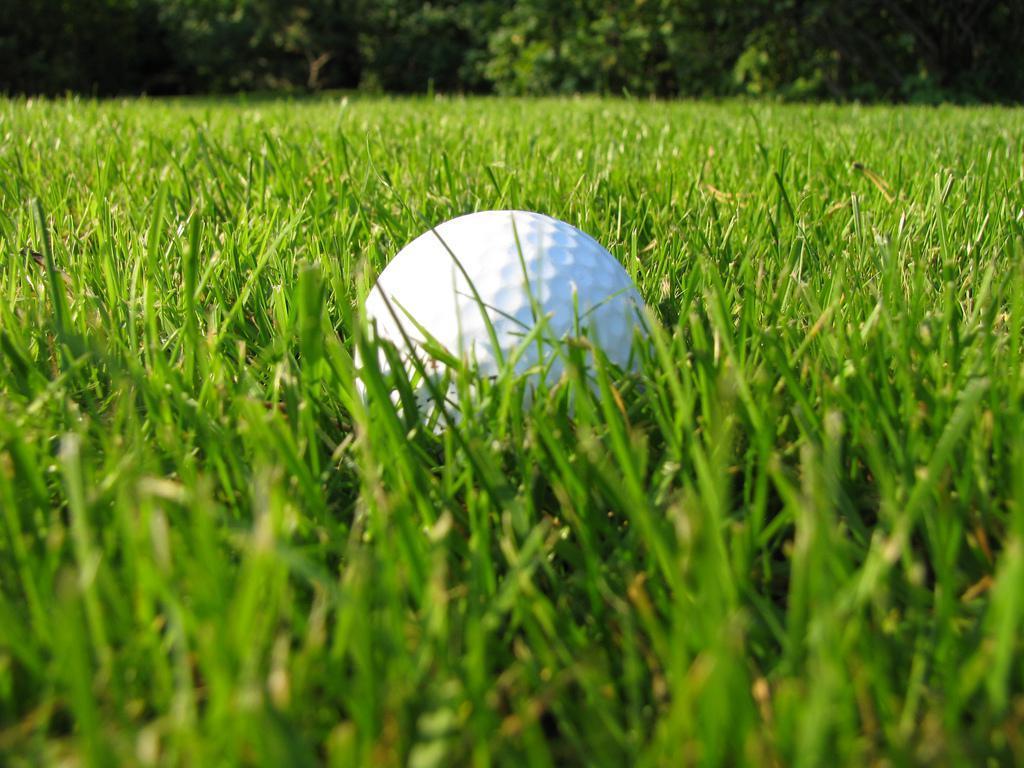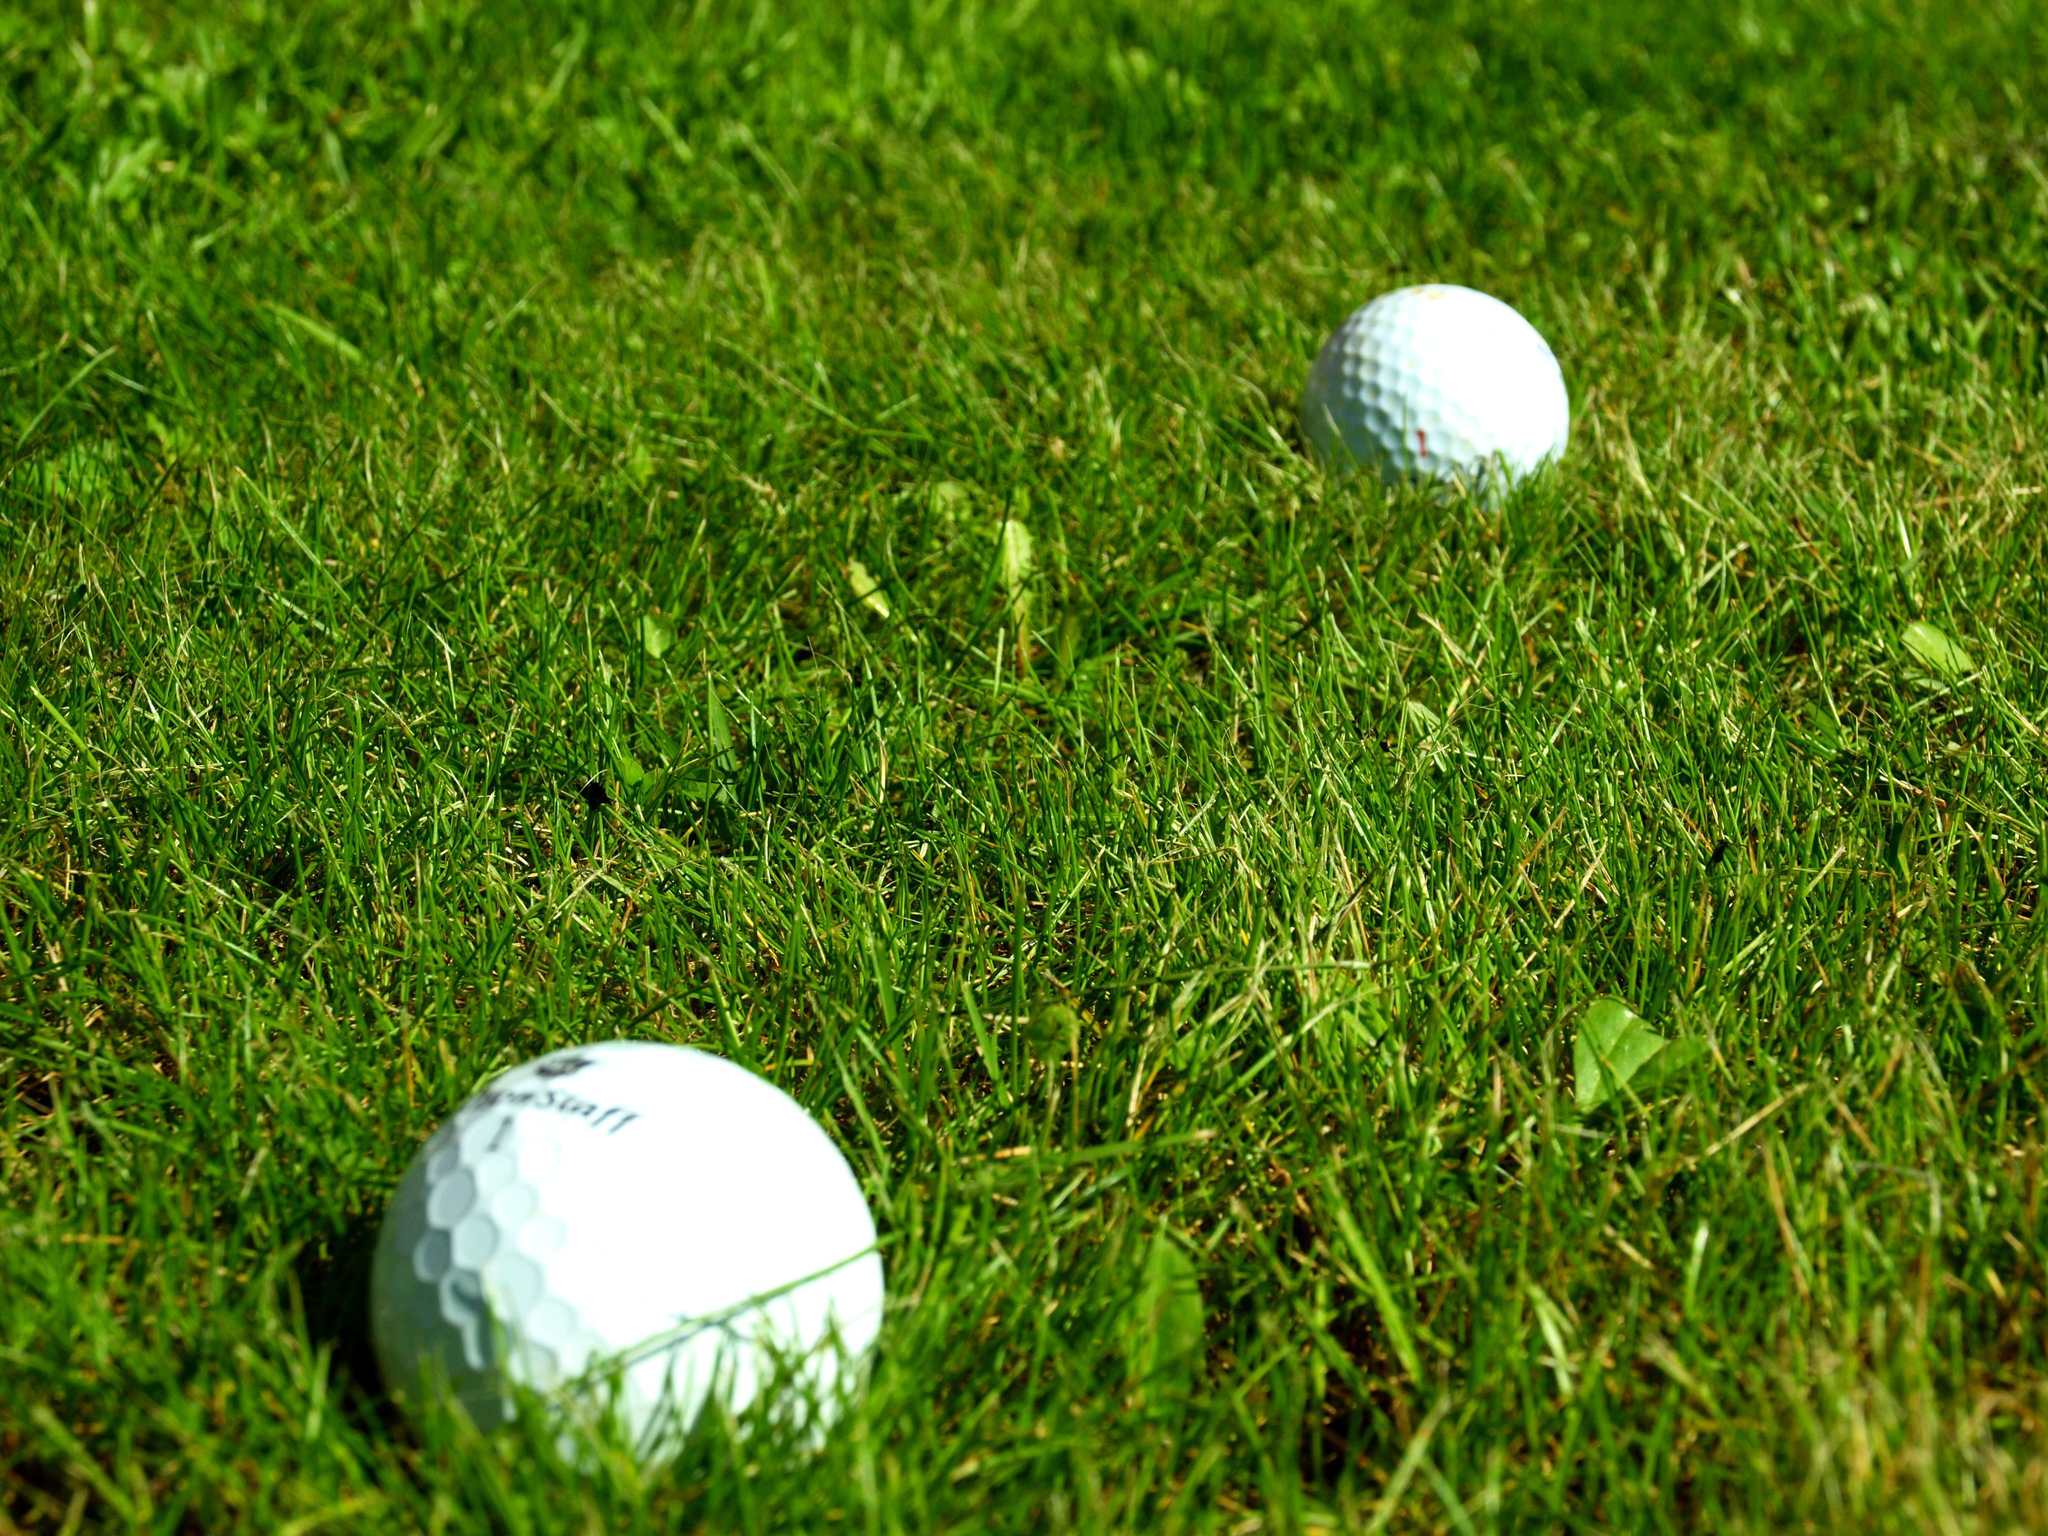The first image is the image on the left, the second image is the image on the right. Assess this claim about the two images: "There is one golf ball resting next to a hole in the image on the right". Correct or not? Answer yes or no. No. 